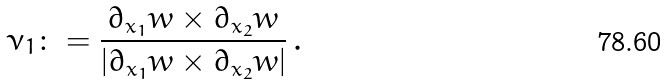Convert formula to latex. <formula><loc_0><loc_0><loc_500><loc_500>\nu _ { 1 } \colon = \frac { \partial _ { x _ { 1 } } w \times \partial _ { x _ { 2 } } w } { | \partial _ { x _ { 1 } } w \times \partial _ { x _ { 2 } } w | } \, .</formula> 